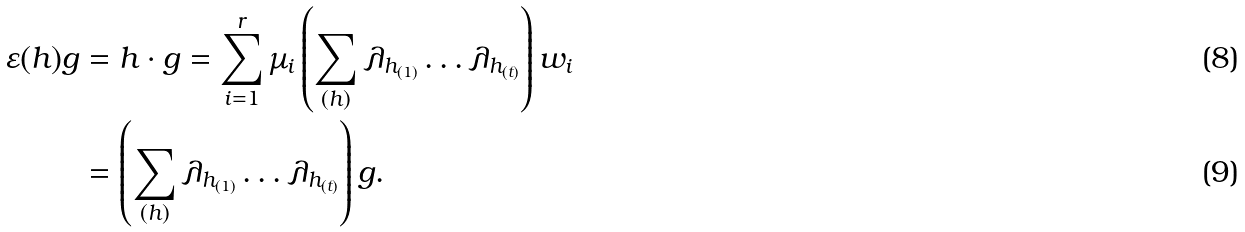<formula> <loc_0><loc_0><loc_500><loc_500>\varepsilon ( h ) g & = h \cdot g = \sum _ { i = 1 } ^ { r } \mu _ { i } \left ( \sum _ { ( h ) } \lambda _ { h _ { ( 1 ) } } \dots \lambda _ { h _ { ( t ) } } \right ) w _ { i } \\ & = \left ( \sum _ { ( h ) } \lambda _ { h _ { ( 1 ) } } \dots \lambda _ { h _ { ( t ) } } \right ) g .</formula> 